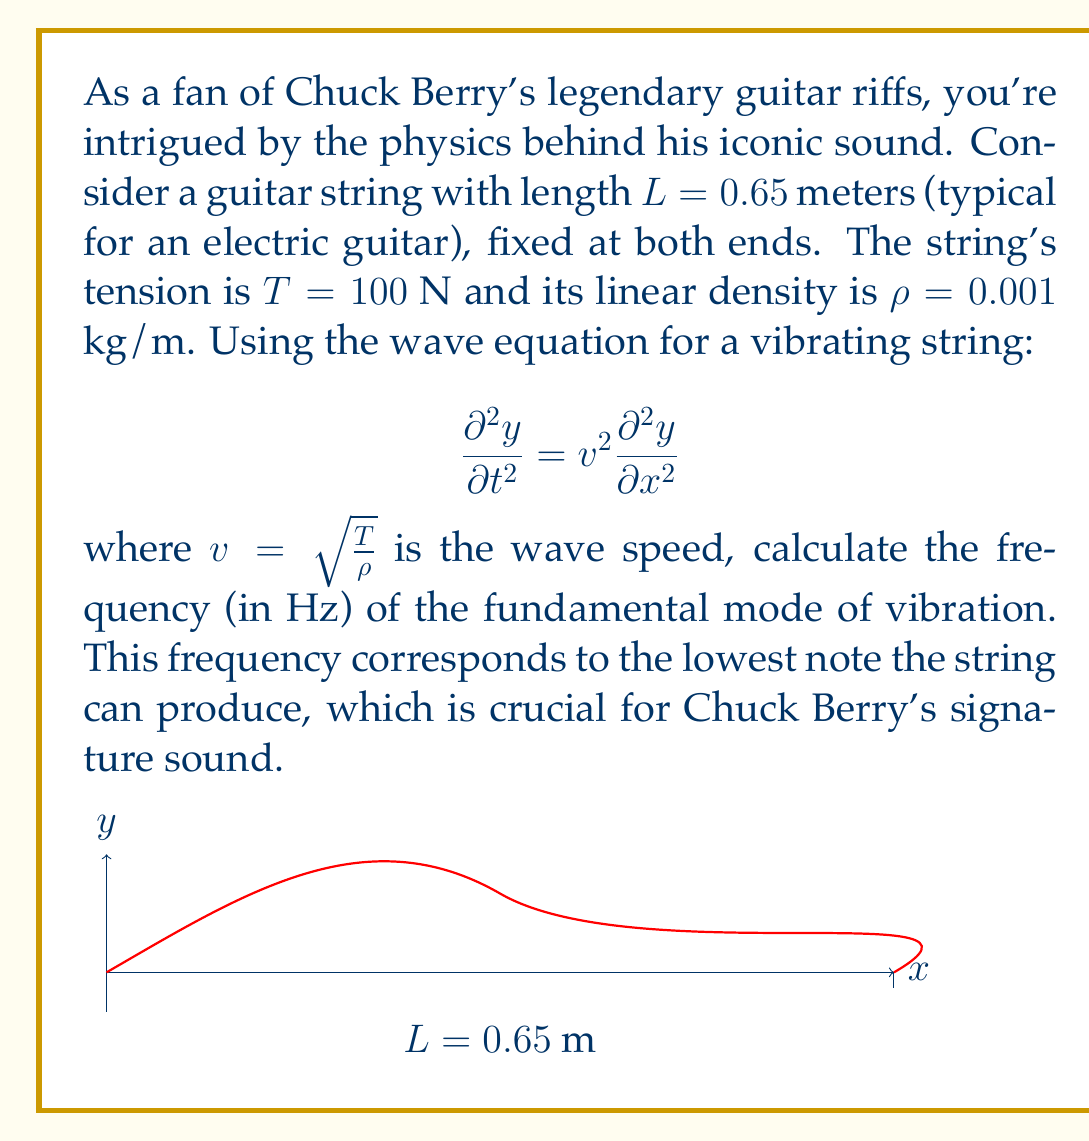Solve this math problem. Let's approach this step-by-step:

1) The wave equation for a vibrating string is given by:

   $$\frac{\partial^2 y}{\partial t^2} = v^2 \frac{\partial^2 y}{\partial x^2}$$

2) The wave speed $v$ is calculated as:

   $$v = \sqrt{\frac{T}{\rho}} = \sqrt{\frac{100}{0.001}} = 316.23 \text{ m/s}$$

3) For a string fixed at both ends, the general solution is:

   $$y(x,t) = \sum_{n=1}^{\infty} A_n \sin(\frac{n\pi x}{L}) \cos(\frac{n\pi v t}{L})$$

4) The fundamental mode corresponds to $n=1$, and its frequency is:

   $$f = \frac{v}{2L}$$

5) Substituting our values:

   $$f = \frac{316.23}{2(0.65)} = 243.25 \text{ Hz}$$

6) Rounding to the nearest whole number:

   $$f \approx 243 \text{ Hz}$$

This frequency corresponds to approximately the note B3, which is indeed in the range of a typical electric guitar's lowest string.
Answer: 243 Hz 